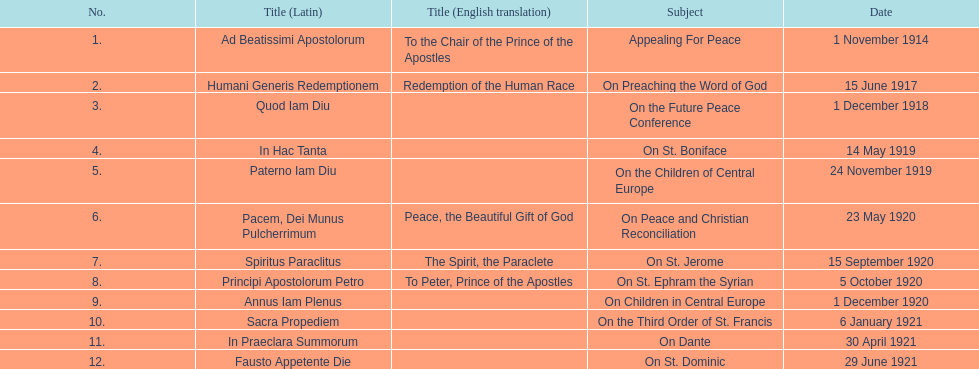Besides january, how many encyclicals were there in 1921? 2. 